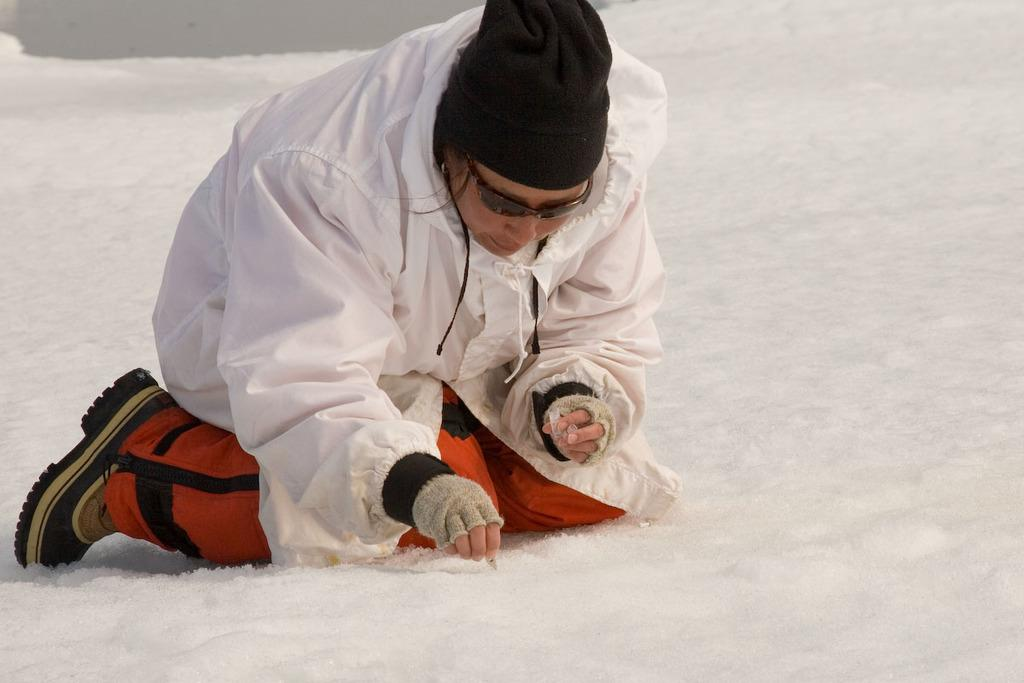What type of headwear is the person wearing in the image? The person is wearing a cap. What type of eye protection is the person wearing in the image? The person is wearing goggles. In which direction is the person looking in the image? The person is looking downwards. What is the condition of the land in the image? The land is covered with snow. What type of cent can be seen in the image? There is no cent present in the image. What type of stew is being prepared in the image? There is no stew being prepared in the image. 